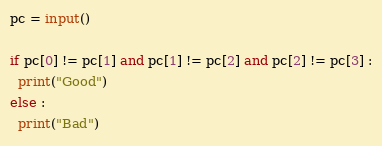Convert code to text. <code><loc_0><loc_0><loc_500><loc_500><_Python_>pc = input()

if pc[0] != pc[1] and pc[1] != pc[2] and pc[2] != pc[3] :
  print("Good")
else :
  print("Bad")
</code> 